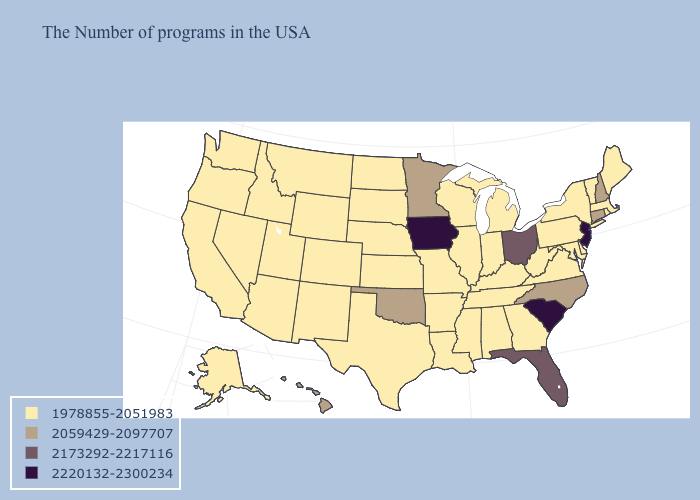Name the states that have a value in the range 2220132-2300234?
Keep it brief. New Jersey, South Carolina, Iowa. What is the value of Missouri?
Concise answer only. 1978855-2051983. Does Oregon have the lowest value in the USA?
Short answer required. Yes. Name the states that have a value in the range 2220132-2300234?
Short answer required. New Jersey, South Carolina, Iowa. Does South Carolina have the highest value in the USA?
Keep it brief. Yes. What is the highest value in the West ?
Concise answer only. 2059429-2097707. What is the value of Connecticut?
Answer briefly. 2059429-2097707. Does New York have a higher value than South Carolina?
Write a very short answer. No. Which states have the highest value in the USA?
Give a very brief answer. New Jersey, South Carolina, Iowa. What is the value of New Mexico?
Concise answer only. 1978855-2051983. Name the states that have a value in the range 2173292-2217116?
Write a very short answer. Ohio, Florida. Which states have the lowest value in the Northeast?
Answer briefly. Maine, Massachusetts, Rhode Island, Vermont, New York, Pennsylvania. Does Kansas have the same value as Louisiana?
Be succinct. Yes. Does New Jersey have the highest value in the Northeast?
Short answer required. Yes. What is the value of Missouri?
Answer briefly. 1978855-2051983. 